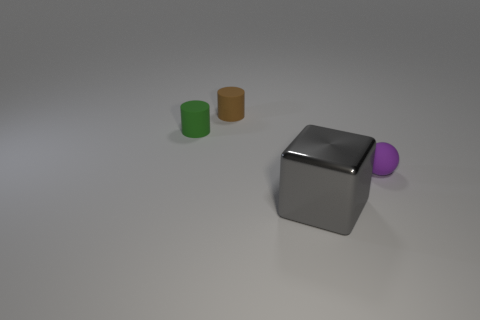There is a matte sphere; does it have the same color as the cylinder in front of the brown rubber object?
Make the answer very short. No. Does the large thing have the same shape as the small object behind the green thing?
Your answer should be very brief. No. Is the number of small brown matte objects greater than the number of big blue rubber blocks?
Provide a short and direct response. Yes. How many other things are there of the same shape as the brown object?
Make the answer very short. 1. What material is the thing that is right of the tiny brown cylinder and behind the large gray block?
Give a very brief answer. Rubber. How big is the brown object?
Make the answer very short. Small. There is a object to the right of the gray block right of the small brown rubber cylinder; how many purple matte balls are to the left of it?
Make the answer very short. 0. The object that is in front of the matte thing that is right of the block is what shape?
Make the answer very short. Cube. There is a brown thing that is the same shape as the green matte thing; what is its size?
Keep it short and to the point. Small. Are there any other things that are the same size as the metallic cube?
Provide a short and direct response. No. 